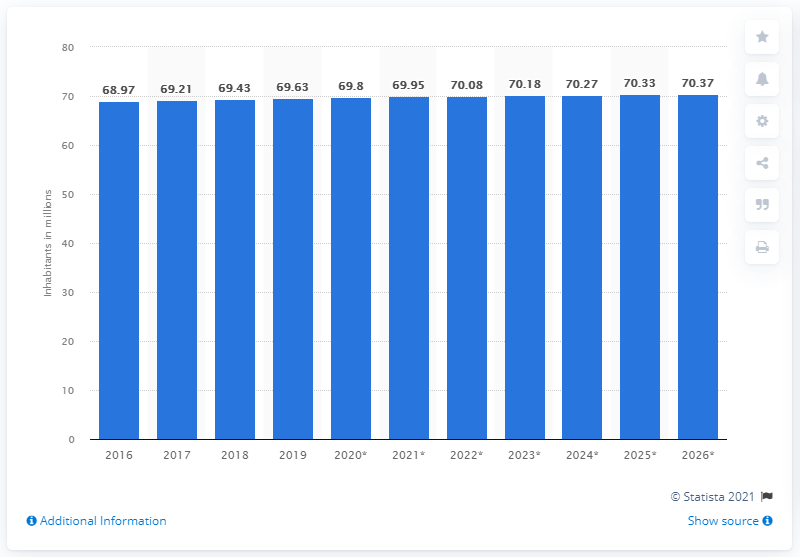Draw attention to some important aspects in this diagram. In 2018, the population of Thailand came to an end. In 2019, the population of Thailand was approximately 70.27 million. 